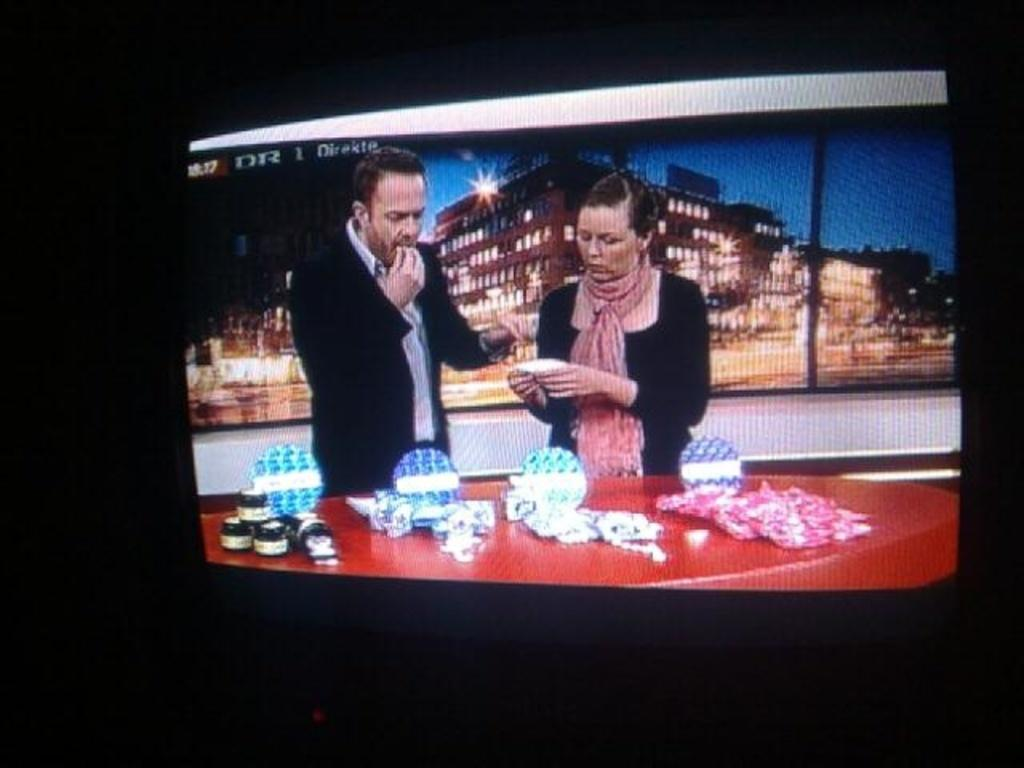<image>
Offer a succinct explanation of the picture presented. a lady and a man are on the television with the letters DB above them 